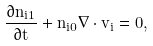Convert formula to latex. <formula><loc_0><loc_0><loc_500><loc_500>\frac { \partial n _ { i 1 } } { \partial t } + n _ { i 0 } \nabla \cdot { v } _ { i } = 0 ,</formula> 